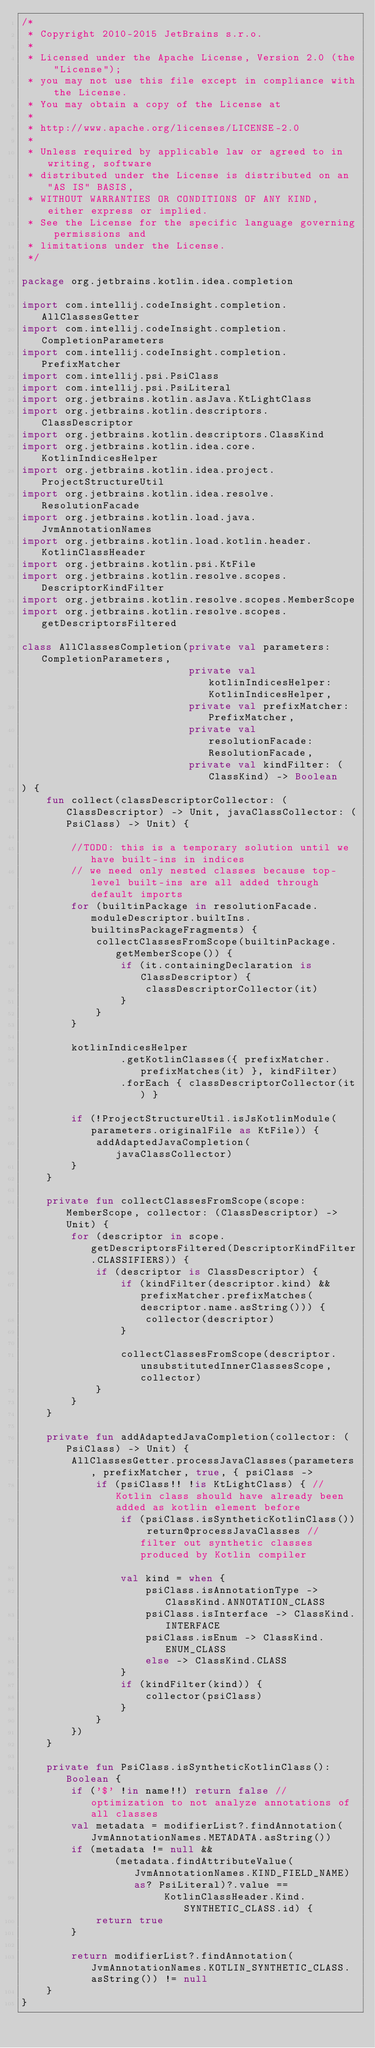<code> <loc_0><loc_0><loc_500><loc_500><_Kotlin_>/*
 * Copyright 2010-2015 JetBrains s.r.o.
 *
 * Licensed under the Apache License, Version 2.0 (the "License");
 * you may not use this file except in compliance with the License.
 * You may obtain a copy of the License at
 *
 * http://www.apache.org/licenses/LICENSE-2.0
 *
 * Unless required by applicable law or agreed to in writing, software
 * distributed under the License is distributed on an "AS IS" BASIS,
 * WITHOUT WARRANTIES OR CONDITIONS OF ANY KIND, either express or implied.
 * See the License for the specific language governing permissions and
 * limitations under the License.
 */

package org.jetbrains.kotlin.idea.completion

import com.intellij.codeInsight.completion.AllClassesGetter
import com.intellij.codeInsight.completion.CompletionParameters
import com.intellij.codeInsight.completion.PrefixMatcher
import com.intellij.psi.PsiClass
import com.intellij.psi.PsiLiteral
import org.jetbrains.kotlin.asJava.KtLightClass
import org.jetbrains.kotlin.descriptors.ClassDescriptor
import org.jetbrains.kotlin.descriptors.ClassKind
import org.jetbrains.kotlin.idea.core.KotlinIndicesHelper
import org.jetbrains.kotlin.idea.project.ProjectStructureUtil
import org.jetbrains.kotlin.idea.resolve.ResolutionFacade
import org.jetbrains.kotlin.load.java.JvmAnnotationNames
import org.jetbrains.kotlin.load.kotlin.header.KotlinClassHeader
import org.jetbrains.kotlin.psi.KtFile
import org.jetbrains.kotlin.resolve.scopes.DescriptorKindFilter
import org.jetbrains.kotlin.resolve.scopes.MemberScope
import org.jetbrains.kotlin.resolve.scopes.getDescriptorsFiltered

class AllClassesCompletion(private val parameters: CompletionParameters,
                           private val kotlinIndicesHelper: KotlinIndicesHelper,
                           private val prefixMatcher: PrefixMatcher,
                           private val resolutionFacade: ResolutionFacade,
                           private val kindFilter: (ClassKind) -> Boolean
) {
    fun collect(classDescriptorCollector: (ClassDescriptor) -> Unit, javaClassCollector: (PsiClass) -> Unit) {

        //TODO: this is a temporary solution until we have built-ins in indices
        // we need only nested classes because top-level built-ins are all added through default imports
        for (builtinPackage in resolutionFacade.moduleDescriptor.builtIns.builtinsPackageFragments) {
            collectClassesFromScope(builtinPackage.getMemberScope()) {
                if (it.containingDeclaration is ClassDescriptor) {
                    classDescriptorCollector(it)
                }
            }
        }

        kotlinIndicesHelper
                .getKotlinClasses({ prefixMatcher.prefixMatches(it) }, kindFilter)
                .forEach { classDescriptorCollector(it) }

        if (!ProjectStructureUtil.isJsKotlinModule(parameters.originalFile as KtFile)) {
            addAdaptedJavaCompletion(javaClassCollector)
        }
    }

    private fun collectClassesFromScope(scope: MemberScope, collector: (ClassDescriptor) -> Unit) {
        for (descriptor in scope.getDescriptorsFiltered(DescriptorKindFilter.CLASSIFIERS)) {
            if (descriptor is ClassDescriptor) {
                if (kindFilter(descriptor.kind) && prefixMatcher.prefixMatches(descriptor.name.asString())) {
                    collector(descriptor)
                }

                collectClassesFromScope(descriptor.unsubstitutedInnerClassesScope, collector)
            }
        }
    }

    private fun addAdaptedJavaCompletion(collector: (PsiClass) -> Unit) {
        AllClassesGetter.processJavaClasses(parameters, prefixMatcher, true, { psiClass ->
            if (psiClass!! !is KtLightClass) { // Kotlin class should have already been added as kotlin element before
                if (psiClass.isSyntheticKotlinClass()) return@processJavaClasses // filter out synthetic classes produced by Kotlin compiler

                val kind = when {
                    psiClass.isAnnotationType -> ClassKind.ANNOTATION_CLASS
                    psiClass.isInterface -> ClassKind.INTERFACE
                    psiClass.isEnum -> ClassKind.ENUM_CLASS
                    else -> ClassKind.CLASS
                }
                if (kindFilter(kind)) {
                    collector(psiClass)
                }
            }
        })
    }

    private fun PsiClass.isSyntheticKotlinClass(): Boolean {
        if ('$' !in name!!) return false // optimization to not analyze annotations of all classes
        val metadata = modifierList?.findAnnotation(JvmAnnotationNames.METADATA.asString())
        if (metadata != null &&
               (metadata.findAttributeValue(JvmAnnotationNames.KIND_FIELD_NAME) as? PsiLiteral)?.value ==
                       KotlinClassHeader.Kind.SYNTHETIC_CLASS.id) {
            return true
        }

        return modifierList?.findAnnotation(JvmAnnotationNames.KOTLIN_SYNTHETIC_CLASS.asString()) != null
    }
}
</code> 